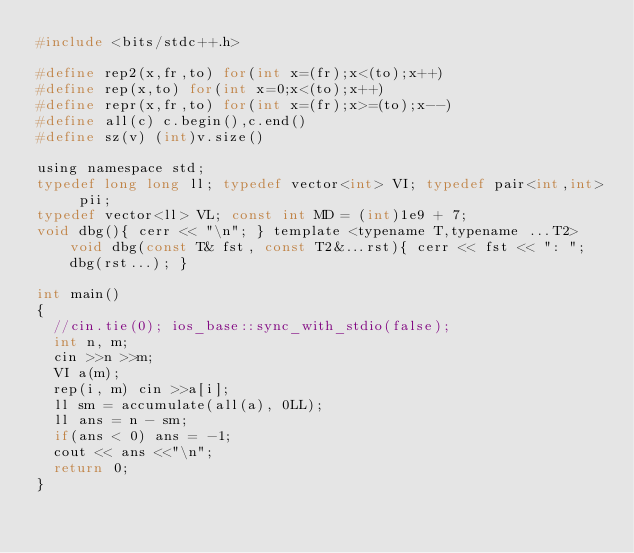<code> <loc_0><loc_0><loc_500><loc_500><_C_>#include <bits/stdc++.h>

#define rep2(x,fr,to) for(int x=(fr);x<(to);x++)
#define rep(x,to) for(int x=0;x<(to);x++)
#define repr(x,fr,to) for(int x=(fr);x>=(to);x--)
#define all(c) c.begin(),c.end()
#define sz(v) (int)v.size()

using namespace std;
typedef long long ll; typedef vector<int> VI; typedef pair<int,int> pii;
typedef vector<ll> VL; const int MD = (int)1e9 + 7;
void dbg(){ cerr << "\n"; } template <typename T,typename ...T2> void dbg(const T& fst, const T2&...rst){ cerr << fst << ": "; dbg(rst...); }

int main()
{
	//cin.tie(0); ios_base::sync_with_stdio(false);
	int n, m;
	cin >>n >>m;
	VI a(m);
	rep(i, m) cin >>a[i];
	ll sm = accumulate(all(a), 0LL);
	ll ans = n - sm;
	if(ans < 0) ans = -1;
	cout << ans <<"\n";
	return 0;
}
</code> 